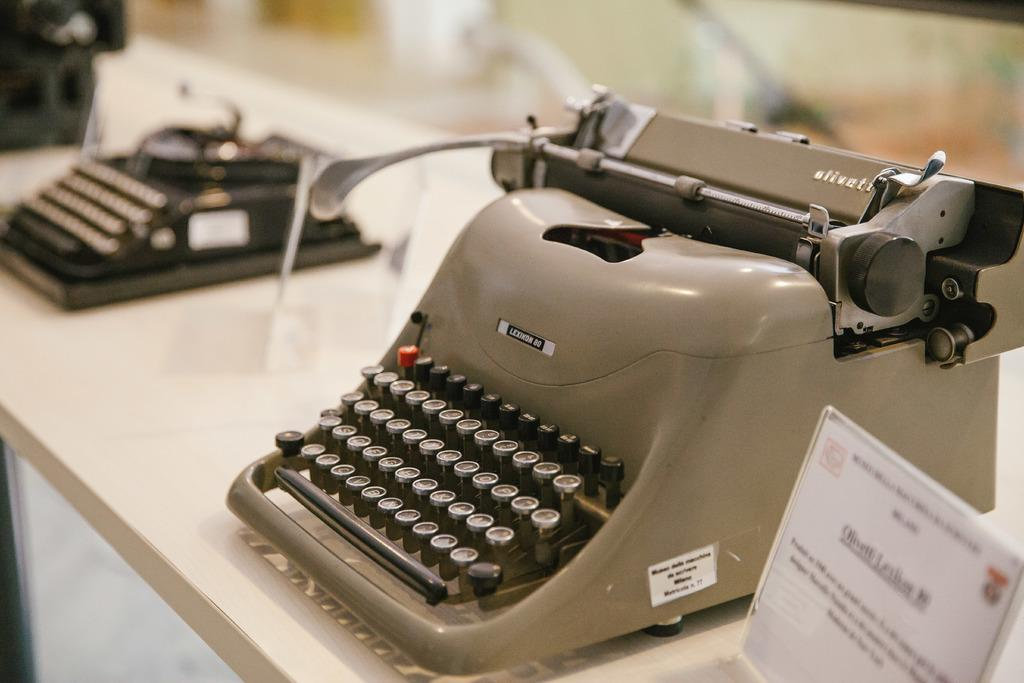<image>
Present a compact description of the photo's key features. Several vintage typewriters including a tan Lexikon 80. 